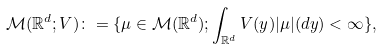Convert formula to latex. <formula><loc_0><loc_0><loc_500><loc_500>\mathcal { M } ( \mathbb { R } ^ { d } ; V ) \colon = \{ \mu \in \mathcal { M } ( \mathbb { R } ^ { d } ) ; \int _ { \mathbb { R } ^ { d } } V ( y ) | \mu | ( d y ) < \infty \} ,</formula> 